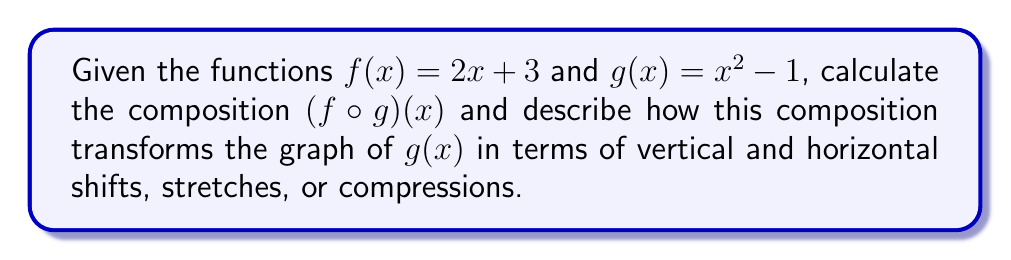Show me your answer to this math problem. To solve this problem, we'll follow these traditional steps:

1) First, we calculate the composition $(f \circ g)(x)$:
   $$(f \circ g)(x) = f(g(x)) = f(x^2 - 1)$$
   
   Substituting $x^2 - 1$ for $x$ in the function $f(x) = 2x + 3$:
   $$(f \circ g)(x) = 2(x^2 - 1) + 3$$
   
   Simplifying:
   $$(f \circ g)(x) = 2x^2 - 2 + 3 = 2x^2 + 1$$

2) Now, let's analyze how this composition transforms the graph of $g(x) = x^2 - 1$:

   a) The coefficient of $x^2$ in $g(x)$ is 1, while in $(f \circ g)(x)$ it's 2. 
      This means the graph is stretched vertically by a factor of 2.
   
   b) The constant term in $g(x)$ is -1, while in $(f \circ g)(x)$ it's +1. 
      This indicates a vertical shift of 2 units upward.

   c) There is no horizontal shift or reflection involved in this transformation.

Therefore, the composition $(f \circ g)(x)$ transforms the graph of $g(x)$ by stretching it vertically by a factor of 2 and then shifting it up by 2 units.
Answer: $(f \circ g)(x) = 2x^2 + 1$

The composition transforms $g(x)$ by:
1) Stretching vertically by a factor of 2
2) Shifting upward by 2 units 